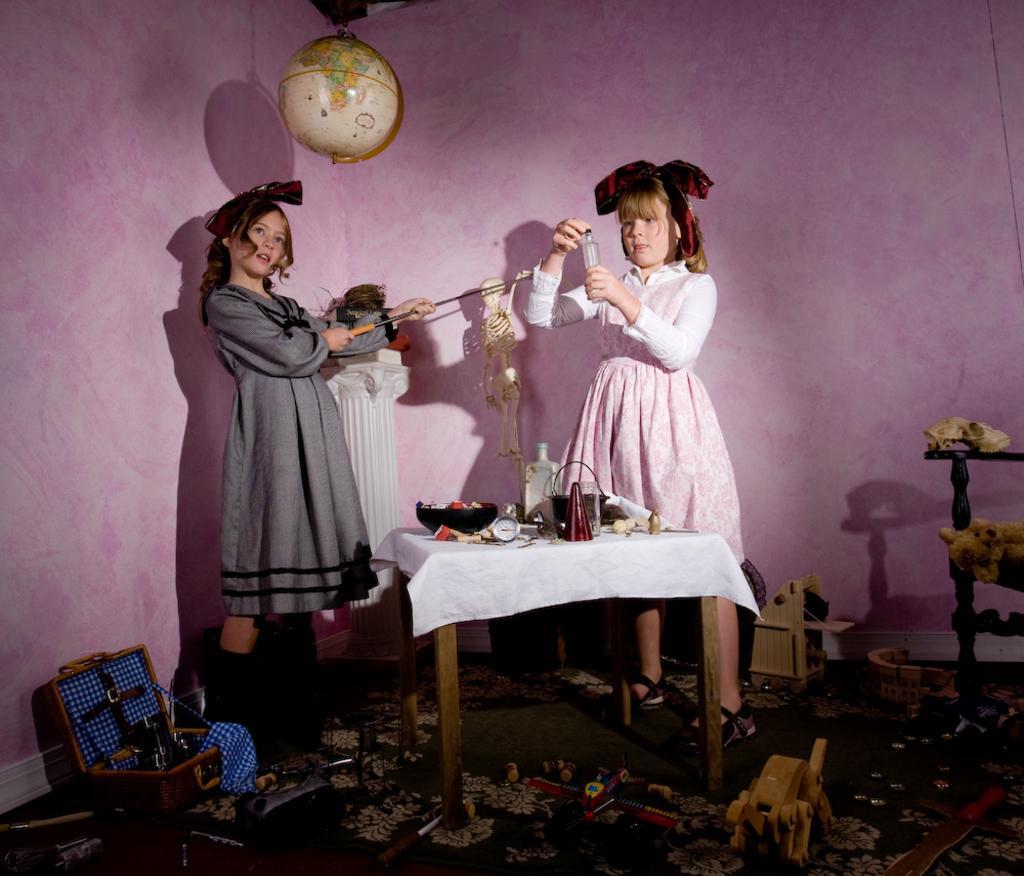In one or two sentences, can you explain what this image depicts? In this picture we can see two persons, on the right side a girl is holding a glass, on the left side girl is holding a stick, in a background we can see a wall, in the bottom there are some toys, there is a table in front of the girl and the table contains one bowl, on the top of the image we can see globe. 